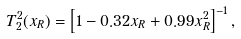Convert formula to latex. <formula><loc_0><loc_0><loc_500><loc_500>T _ { 2 } ^ { 2 } ( x _ { R } ) = \left [ 1 - 0 . 3 2 x _ { R } + 0 . 9 9 x _ { R } ^ { 2 } \right ] ^ { - 1 } ,</formula> 